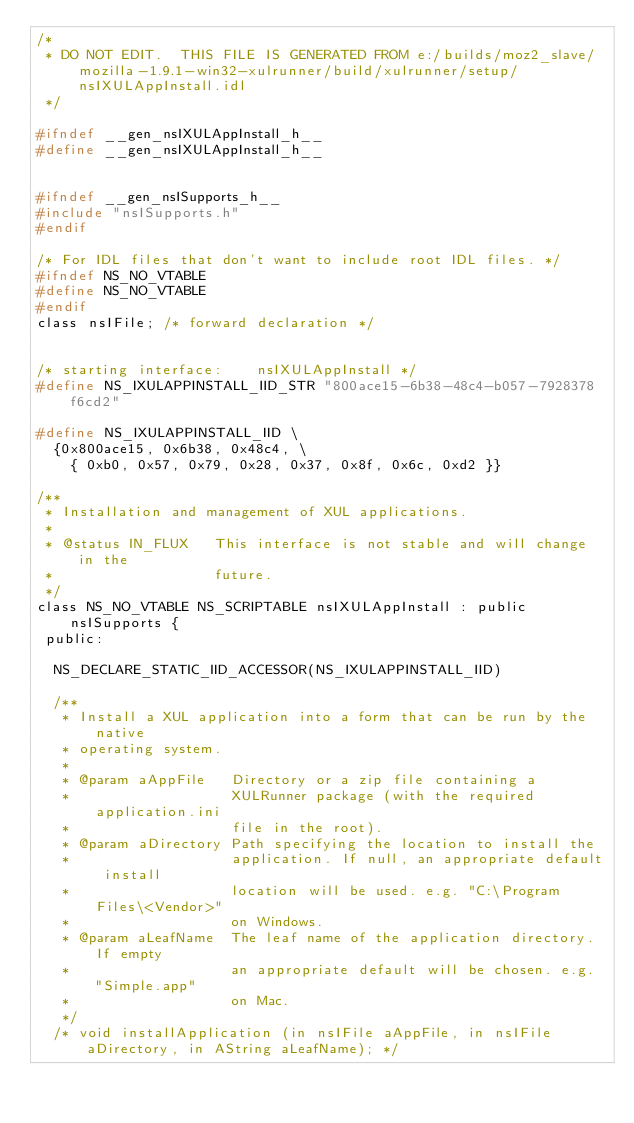<code> <loc_0><loc_0><loc_500><loc_500><_C_>/*
 * DO NOT EDIT.  THIS FILE IS GENERATED FROM e:/builds/moz2_slave/mozilla-1.9.1-win32-xulrunner/build/xulrunner/setup/nsIXULAppInstall.idl
 */

#ifndef __gen_nsIXULAppInstall_h__
#define __gen_nsIXULAppInstall_h__


#ifndef __gen_nsISupports_h__
#include "nsISupports.h"
#endif

/* For IDL files that don't want to include root IDL files. */
#ifndef NS_NO_VTABLE
#define NS_NO_VTABLE
#endif
class nsIFile; /* forward declaration */


/* starting interface:    nsIXULAppInstall */
#define NS_IXULAPPINSTALL_IID_STR "800ace15-6b38-48c4-b057-7928378f6cd2"

#define NS_IXULAPPINSTALL_IID \
  {0x800ace15, 0x6b38, 0x48c4, \
    { 0xb0, 0x57, 0x79, 0x28, 0x37, 0x8f, 0x6c, 0xd2 }}

/**
 * Installation and management of XUL applications.
 *
 * @status IN_FLUX   This interface is not stable and will change in the
 *                   future.
 */
class NS_NO_VTABLE NS_SCRIPTABLE nsIXULAppInstall : public nsISupports {
 public: 

  NS_DECLARE_STATIC_IID_ACCESSOR(NS_IXULAPPINSTALL_IID)

  /**
   * Install a XUL application into a form that can be run by the native
   * operating system.
   *
   * @param aAppFile   Directory or a zip file containing a 
   *                   XULRunner package (with the required application.ini
   *                   file in the root).
   * @param aDirectory Path specifying the location to install the
   *                   application. If null, an appropriate default install
   *                   location will be used. e.g. "C:\Program Files\<Vendor>"
   *                   on Windows.
   * @param aLeafName  The leaf name of the application directory. If empty
   *                   an appropriate default will be chosen. e.g. "Simple.app"
   *                   on Mac.
   */
  /* void installApplication (in nsIFile aAppFile, in nsIFile aDirectory, in AString aLeafName); */</code> 